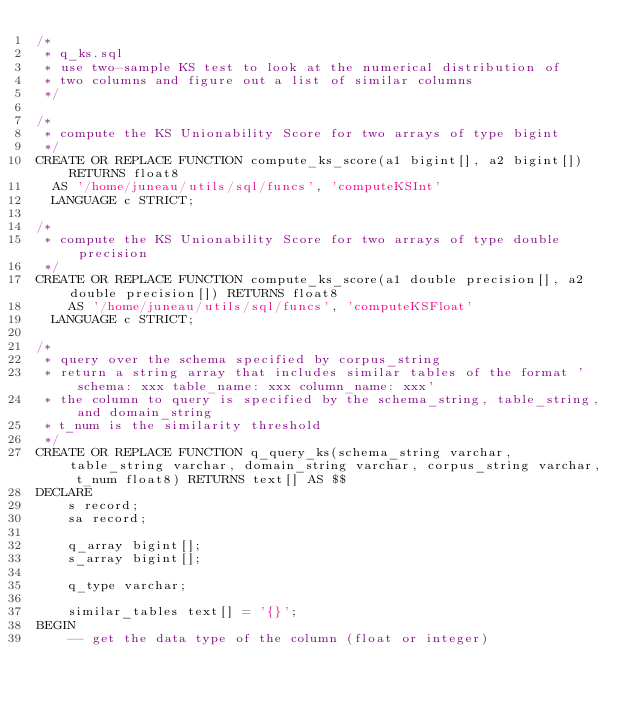<code> <loc_0><loc_0><loc_500><loc_500><_SQL_>/*
 * q_ks.sql
 * use two-sample KS test to look at the numerical distribution of
 * two columns and figure out a list of similar columns
 */

/*
 * compute the KS Unionability Score for two arrays of type bigint
 */
CREATE OR REPLACE FUNCTION compute_ks_score(a1 bigint[], a2 bigint[]) RETURNS float8
  AS '/home/juneau/utils/sql/funcs', 'computeKSInt'
  LANGUAGE c STRICT;

/*
 * compute the KS Unionability Score for two arrays of type double precision
 */
CREATE OR REPLACE FUNCTION compute_ks_score(a1 double precision[], a2 double precision[]) RETURNS float8
	AS '/home/juneau/utils/sql/funcs', 'computeKSFloat'
  LANGUAGE c STRICT;

/*
 * query over the schema specified by corpus_string
 * return a string array that includes similar tables of the format 'schema: xxx table_name: xxx column_name: xxx'
 * the column to query is specified by the schema_string, table_string, and domain_string
 * t_num is the similarity threshold
 */
CREATE OR REPLACE FUNCTION q_query_ks(schema_string varchar, table_string varchar, domain_string varchar, corpus_string varchar, t_num float8) RETURNS text[] AS $$
DECLARE
	s record;
	sa record;

	q_array bigint[];
	s_array bigint[];

	q_type varchar;

	similar_tables text[] = '{}';
BEGIN
	-- get the data type of the column (float or integer)</code> 